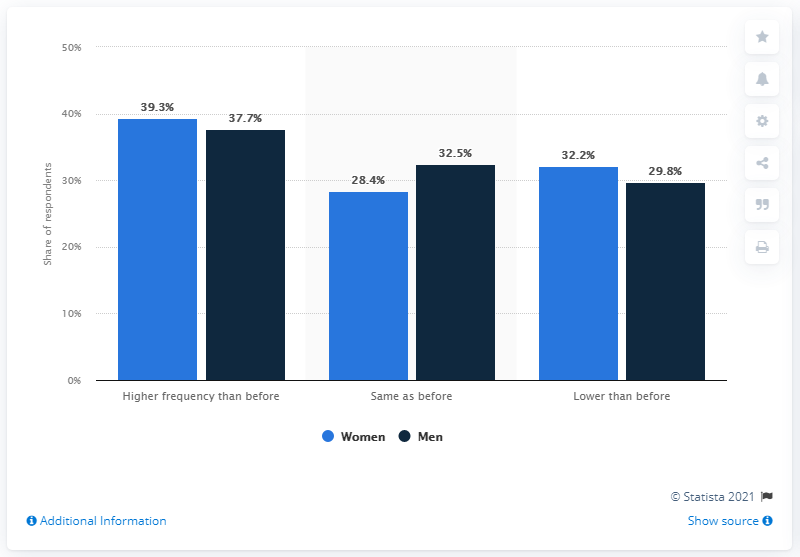Specify some key components in this picture. During the COVID-19 pandemic, 39.3% of women in Mexico reported an increase in the usage of sex video calls and sexting, according to a recent study. 